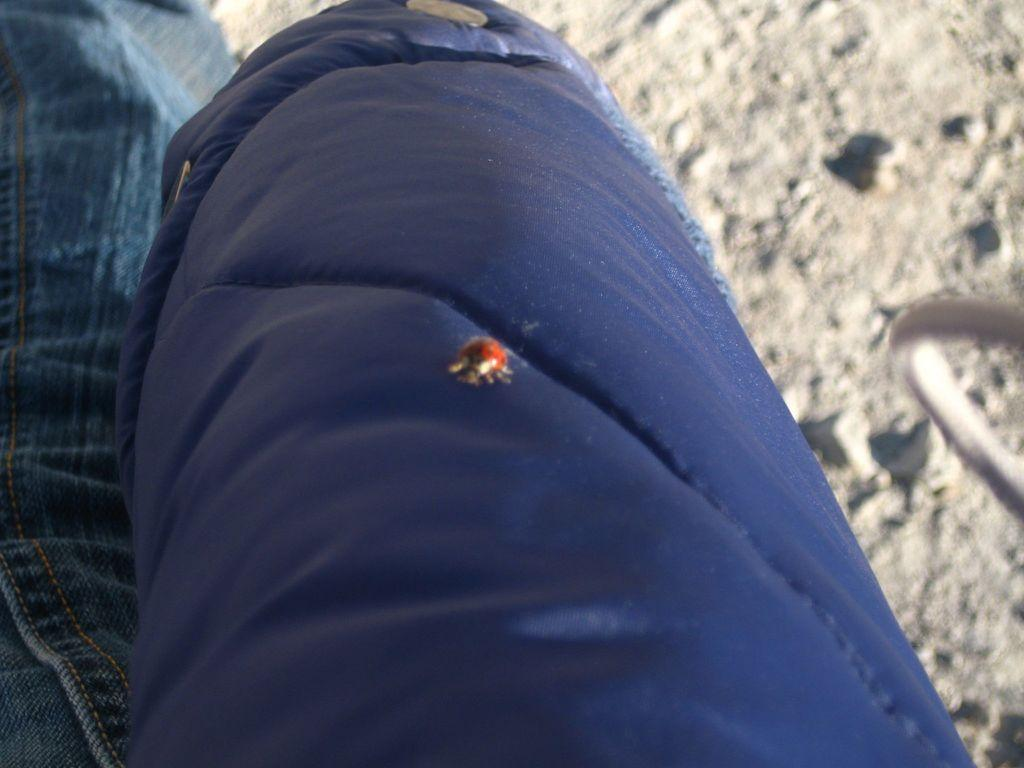What color is the object in the image? There is a blue object in the image. What is on the blue object? There is a red bug on the blue object. What type of material can be seen on the left side of the image? There is jeans material on the left side of the image. How would you describe the background of the image? The background of the image is blurred. What type of vegetable is growing on the blue object in the image? There is no vegetable present in the image; it features a blue object with a red bug on it. How does the thumb interact with the red bug in the image? There is no thumb present in the image, and therefore no interaction with the red bug can be observed. 